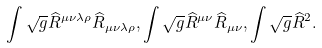<formula> <loc_0><loc_0><loc_500><loc_500>\int \sqrt { g } \widehat { R } ^ { \mu \nu \lambda \rho } \widehat { R } _ { \mu \nu \lambda \rho } , \int \sqrt { g } \widehat { R } ^ { \mu \nu } \widehat { R } _ { \mu \nu } , \int \sqrt { g } \widehat { R } ^ { 2 } .</formula> 